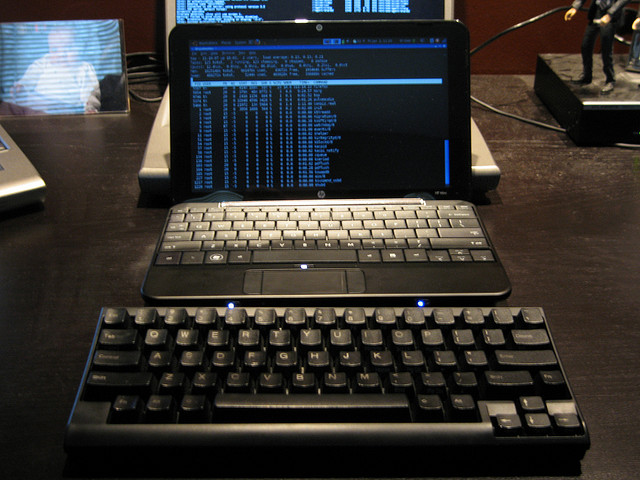<image>What is the brand name on the keyboard? I am not sure about the brand name on the keyboard. It could be Dell, IBM, or HP. What is the brand name on the keyboard? I don't know the brand name on the keyboard. It can be 'no name', 'none', 'na', 'dell', 'ibm', 'no brand', 'hp', or 'dell'. 